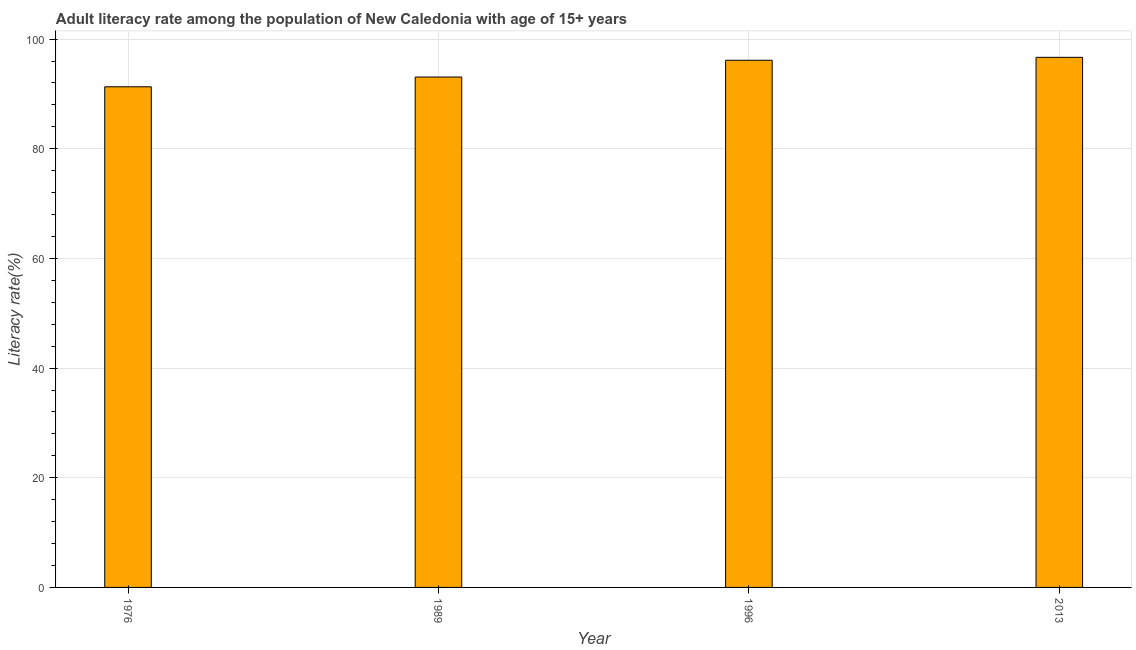Does the graph contain any zero values?
Give a very brief answer. No. What is the title of the graph?
Your response must be concise. Adult literacy rate among the population of New Caledonia with age of 15+ years. What is the label or title of the X-axis?
Ensure brevity in your answer.  Year. What is the label or title of the Y-axis?
Ensure brevity in your answer.  Literacy rate(%). What is the adult literacy rate in 1976?
Offer a very short reply. 91.3. Across all years, what is the maximum adult literacy rate?
Offer a very short reply. 96.67. Across all years, what is the minimum adult literacy rate?
Provide a short and direct response. 91.3. In which year was the adult literacy rate minimum?
Provide a short and direct response. 1976. What is the sum of the adult literacy rate?
Your response must be concise. 377.19. What is the difference between the adult literacy rate in 1989 and 1996?
Your answer should be compact. -3.06. What is the average adult literacy rate per year?
Your answer should be compact. 94.3. What is the median adult literacy rate?
Give a very brief answer. 94.61. In how many years, is the adult literacy rate greater than 16 %?
Offer a very short reply. 4. Do a majority of the years between 2013 and 1989 (inclusive) have adult literacy rate greater than 12 %?
Make the answer very short. Yes. Is the difference between the adult literacy rate in 1996 and 2013 greater than the difference between any two years?
Your answer should be very brief. No. What is the difference between the highest and the second highest adult literacy rate?
Your response must be concise. 0.53. What is the difference between the highest and the lowest adult literacy rate?
Give a very brief answer. 5.37. In how many years, is the adult literacy rate greater than the average adult literacy rate taken over all years?
Your answer should be very brief. 2. How many bars are there?
Make the answer very short. 4. Are all the bars in the graph horizontal?
Give a very brief answer. No. How many years are there in the graph?
Provide a succinct answer. 4. What is the difference between two consecutive major ticks on the Y-axis?
Your answer should be compact. 20. Are the values on the major ticks of Y-axis written in scientific E-notation?
Provide a succinct answer. No. What is the Literacy rate(%) of 1976?
Provide a short and direct response. 91.3. What is the Literacy rate(%) in 1989?
Your response must be concise. 93.08. What is the Literacy rate(%) of 1996?
Your answer should be very brief. 96.14. What is the Literacy rate(%) in 2013?
Give a very brief answer. 96.67. What is the difference between the Literacy rate(%) in 1976 and 1989?
Offer a terse response. -1.78. What is the difference between the Literacy rate(%) in 1976 and 1996?
Your response must be concise. -4.84. What is the difference between the Literacy rate(%) in 1976 and 2013?
Provide a short and direct response. -5.37. What is the difference between the Literacy rate(%) in 1989 and 1996?
Provide a short and direct response. -3.06. What is the difference between the Literacy rate(%) in 1989 and 2013?
Provide a succinct answer. -3.59. What is the difference between the Literacy rate(%) in 1996 and 2013?
Give a very brief answer. -0.53. What is the ratio of the Literacy rate(%) in 1976 to that in 1989?
Ensure brevity in your answer.  0.98. What is the ratio of the Literacy rate(%) in 1976 to that in 1996?
Give a very brief answer. 0.95. What is the ratio of the Literacy rate(%) in 1976 to that in 2013?
Your answer should be compact. 0.94. What is the ratio of the Literacy rate(%) in 1989 to that in 1996?
Your response must be concise. 0.97. What is the ratio of the Literacy rate(%) in 1989 to that in 2013?
Provide a short and direct response. 0.96. 